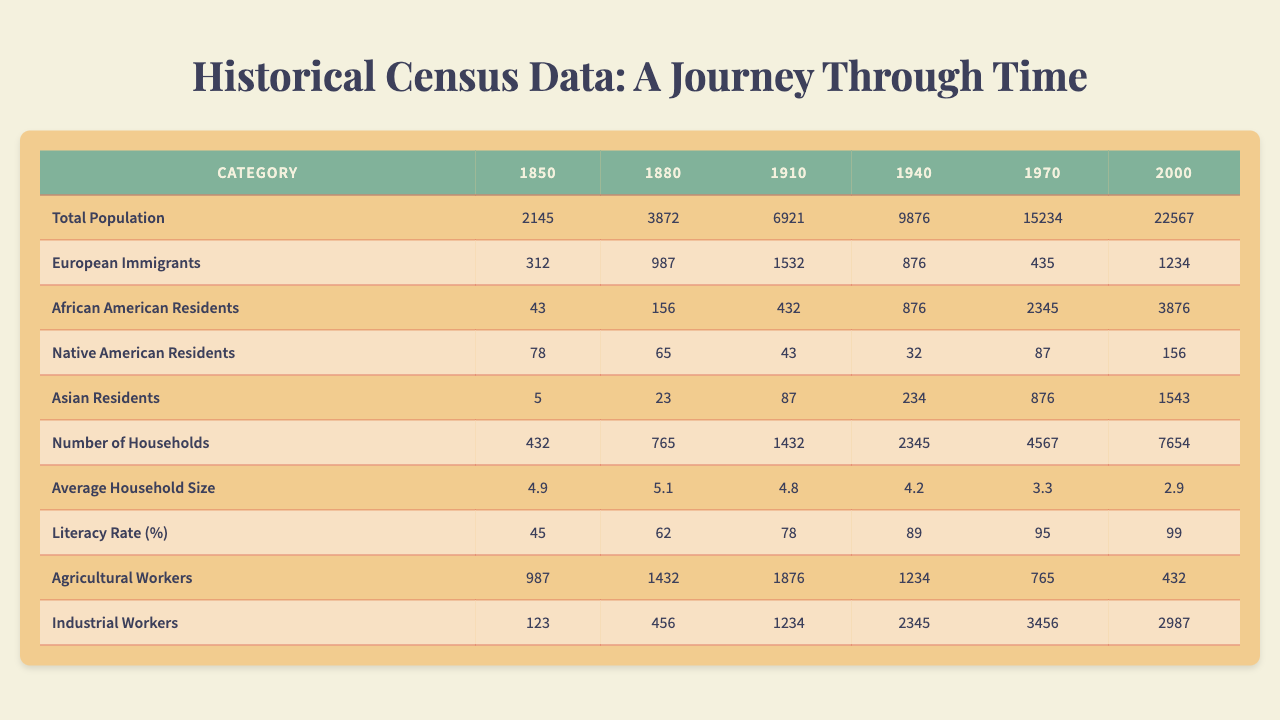What was the total population in 1910? The table shows the total population for each year, and for 1910 it indicates a value of 6921.
Answer: 6921 What is the percentage increase in the total population from 1850 to 2000? The total population in 1850 was 2145 and in 2000 it was 22567. The increase is 22567 - 2145 = 20422. The percentage increase is (20422 / 2145) * 100 = 951.3%.
Answer: 951.3% How many African American residents were recorded in 1940? According to the table, the number of African American residents in 1940 is 876.
Answer: 876 Is the literacy rate higher in 1940 than in 1910? The literacy rate for 1940 is 89% while for 1910 it is 78%. Since 89% is greater than 78%, the statement is true.
Answer: Yes What was the average household size in 1970? The table indicates the average household size for 1970 is 3.3.
Answer: 3.3 What was the total number of agricultural workers in 1880 and 1940 combined? The number of agricultural workers in 1880 is 1432 and in 1940 is 1234. Their total is 1432 + 1234 = 2666.
Answer: 2666 How did the number of households change from 1940 to 2000? The number of households in 1940 was 2345 and in 2000 it was 7654. The increase is 7654 - 2345 = 5309.
Answer: 5309 Which category had the lowest recorded value in 1910? In 1910, the recorded categories with values are: European Immigrants (1532), African American Residents (432), Native American Residents (43), Asian Residents (87), Agricultural Workers (1876), Industrial Workers (1234). The lowest is Native American Residents with 43.
Answer: Native American Residents What was the growth trend for Asian residents from 1850 to 2000? The Asian residents grew from 5 in 1850, increasing to 1543 in 2000. This represents consistent growth across the years.
Answer: Consistent growth What is the difference in the number of industrial workers between 1970 and 1910? The number of industrial workers in 1970 is 3456 and in 1910 is 1234. The difference is 3456 - 1234 = 2222.
Answer: 2222 